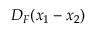<formula> <loc_0><loc_0><loc_500><loc_500>D _ { F } ( x _ { 1 } - x _ { 2 } )</formula> 